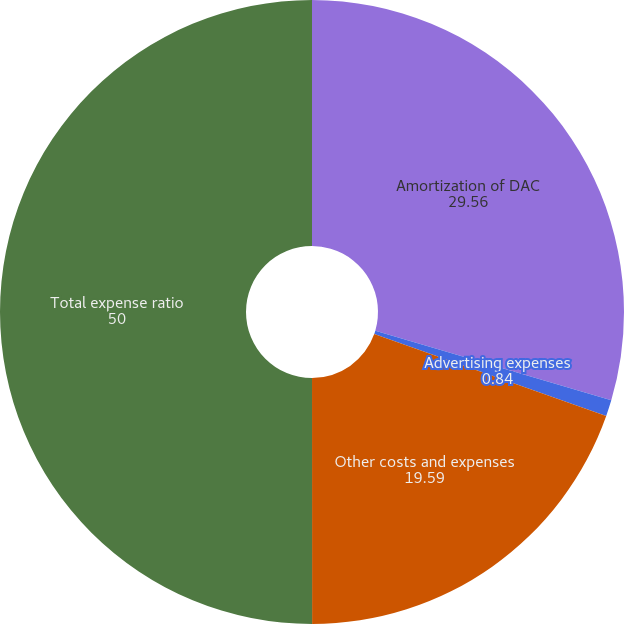<chart> <loc_0><loc_0><loc_500><loc_500><pie_chart><fcel>Amortization of DAC<fcel>Advertising expenses<fcel>Other costs and expenses<fcel>Total expense ratio<nl><fcel>29.56%<fcel>0.84%<fcel>19.59%<fcel>50.0%<nl></chart> 